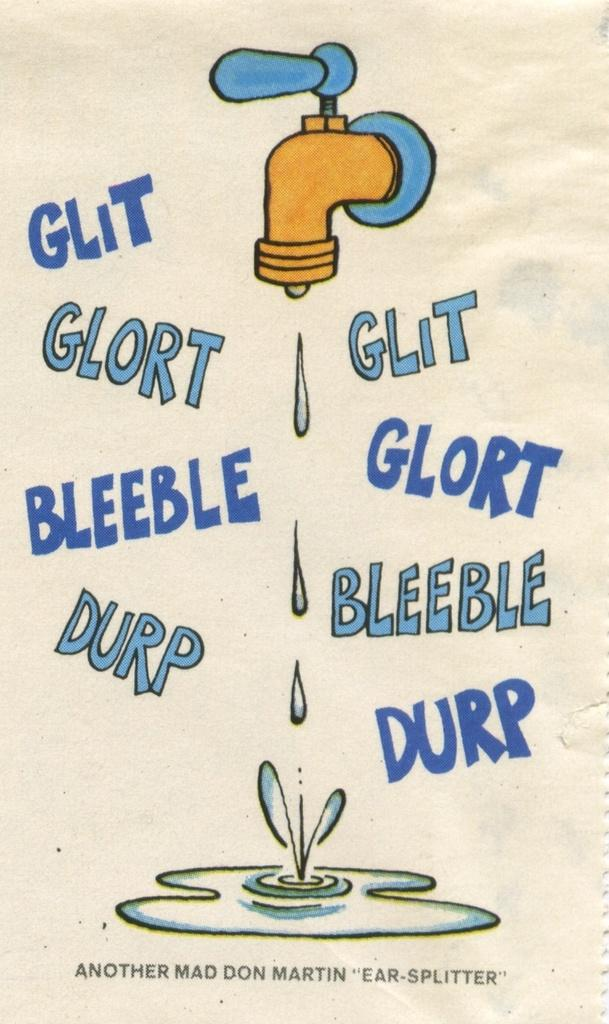Provide a one-sentence caption for the provided image. A faucet drips water into a puddle, below the puddle it says Another Mad Don Martin Ear Splitter. 